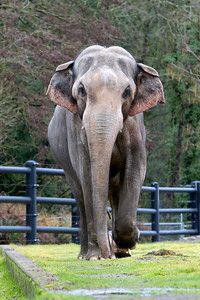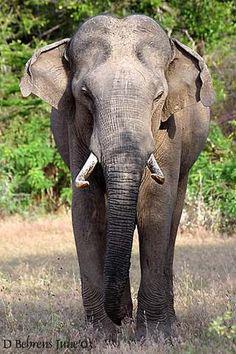The first image is the image on the left, the second image is the image on the right. Assess this claim about the two images: "An enclosure is seen behind one of the elephants.". Correct or not? Answer yes or no. Yes. The first image is the image on the left, the second image is the image on the right. Considering the images on both sides, is "An image shows a young elephant standing next to at least one adult elephant." valid? Answer yes or no. No. 